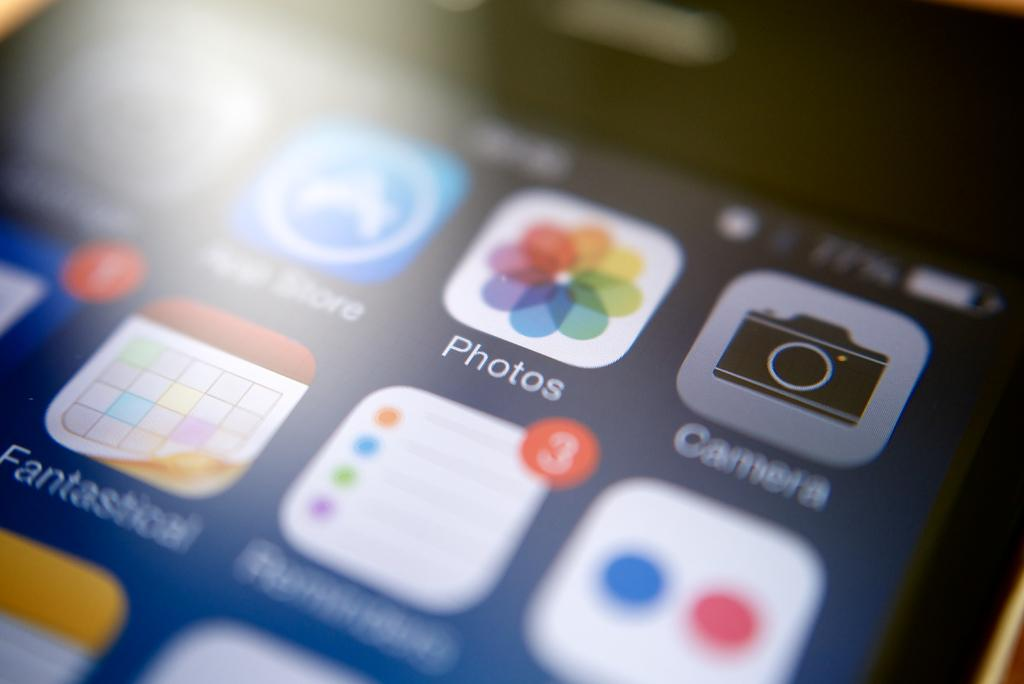<image>
Write a terse but informative summary of the picture. An iPhone is showing the home screen and the Photos icon. 